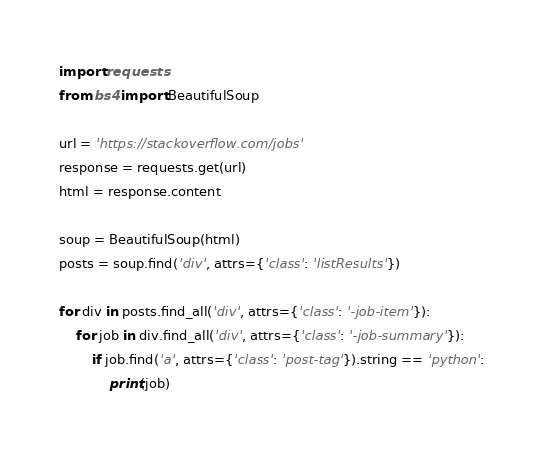<code> <loc_0><loc_0><loc_500><loc_500><_Python_>import requests
from bs4 import BeautifulSoup

url = 'https://stackoverflow.com/jobs'
response = requests.get(url)
html = response.content

soup = BeautifulSoup(html)
posts = soup.find('div', attrs={'class': 'listResults'})

for div in posts.find_all('div', attrs={'class': '-job-item'}):
    for job in div.find_all('div', attrs={'class': '-job-summary'}):
        if job.find('a', attrs={'class': 'post-tag'}).string == 'python':
            print(job)</code> 